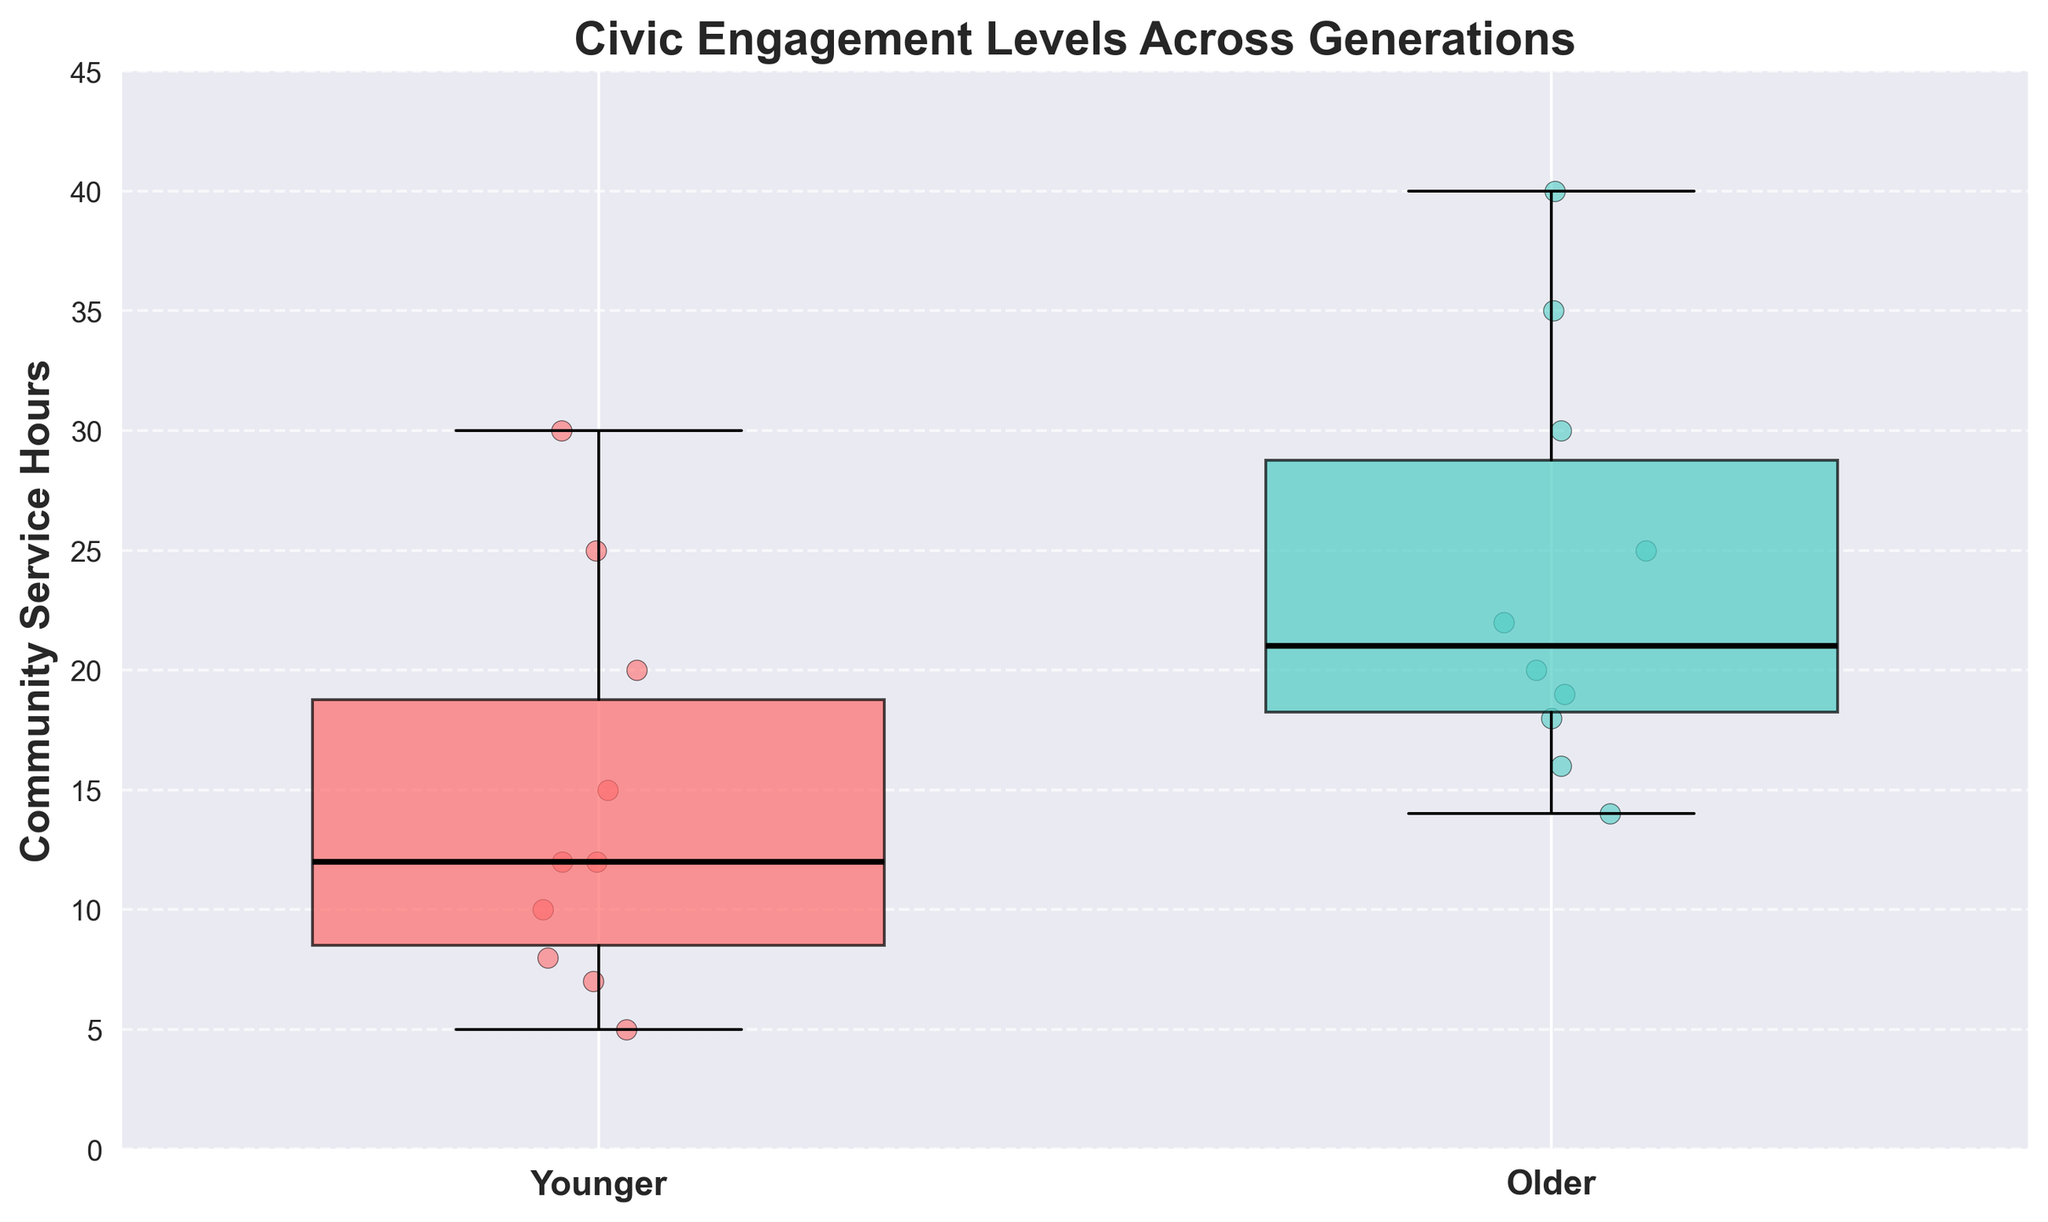What is the title of the plot? The title of the plot is at the top and reads "Civic Engagement Levels Across Generations."
Answer: Civic Engagement Levels Across Generations What are the two groups represented in the box plot? The two groups can be identified from the x-axis labels, which are "Younger" and "Older."
Answer: Younger and Older Which generation has a higher median value for community service hours? You can identify the median from the thicker black line within each box. For the older generation, the median is higher than for the younger generation.
Answer: Older What is the maximum value of community service hours for the older generation? Look at the top whisker of the older generation's box plot and the scatter points; the highest value is 40.
Answer: 40 How do the ranges of community service hours compare between the two generations? The range can be determined by looking at the length of the whiskers. The older generation has a wider range (from approximately 14 to 40) compared to the younger generation (from approximately 5 to 30).
Answer: Older generation has a wider range What is the interquartile range (IQR) for the younger generation? The IQR is the range between the 25th percentile (bottom of the box) and the 75th percentile (top of the box). For the younger generation, the bottom of the box is around 8 hours and the top is around 20 hours, making the IQR 20-8 = 12.
Answer: 12 How many data points are there for the younger generation? Count the individual scatter points on the plot for the younger generation; there are 10 points.
Answer: 10 Which group exhibits more variability in their community service hours? Variability is indicated by the size of the IQR and length of the whiskers. The older generation shows more variability as their IQR and whiskers are longer.
Answer: Older What is the lower quartile (Q1) for the older generation? The lower quartile is found at the bottom of the box for the older generation which is approximately 16 hours.
Answer: 16 Which generation shows any outliers, if present? Look for points that are isolated far from the box and whiskers. Neither of the two groups shows distinct outliers beyond the whiskers.
Answer: None 